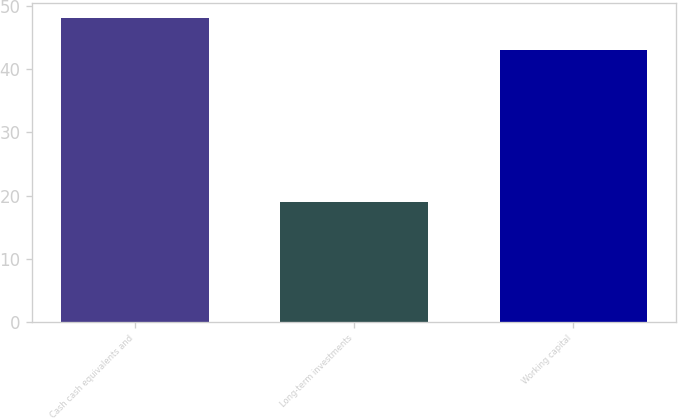<chart> <loc_0><loc_0><loc_500><loc_500><bar_chart><fcel>Cash cash equivalents and<fcel>Long-term investments<fcel>Working capital<nl><fcel>48<fcel>19<fcel>43<nl></chart> 